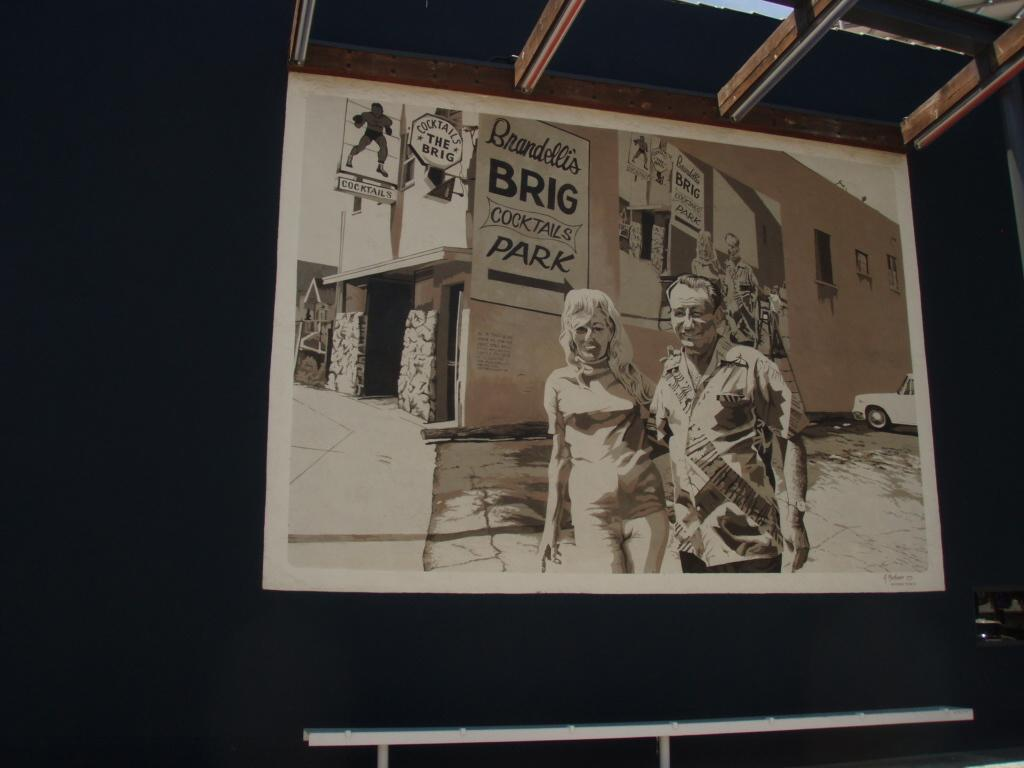<image>
Give a short and clear explanation of the subsequent image. Black and white photo of a man and women taken in front of Brandelli's Brig Cocktails Park. 